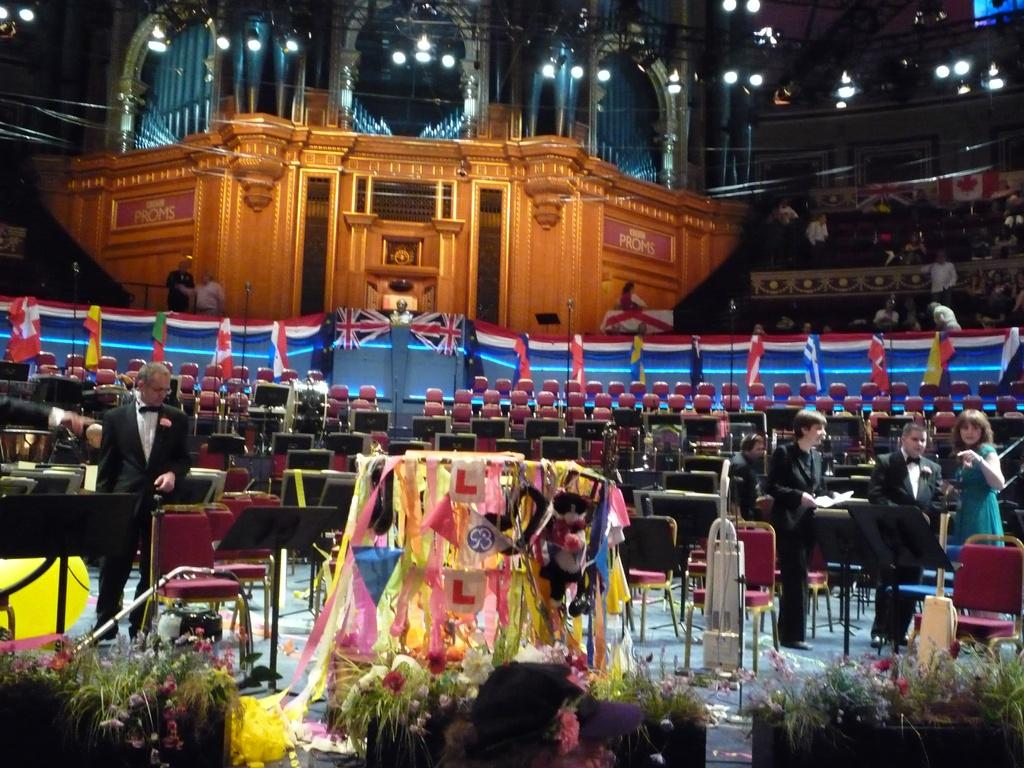What type of living organisms can be seen in the image? There are flowers in the image. What else can be seen in the image besides the flowers? There are people standing and objects in the image. What is the material of the wall in the image? The wall in the image is made of wood. What is present on the ceiling in the image? There are lights on the ceiling in the image. What does the dad say about his stomach in the image? There is no mention of a dad or any discussion about a stomach in the image. 